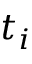<formula> <loc_0><loc_0><loc_500><loc_500>t _ { i }</formula> 